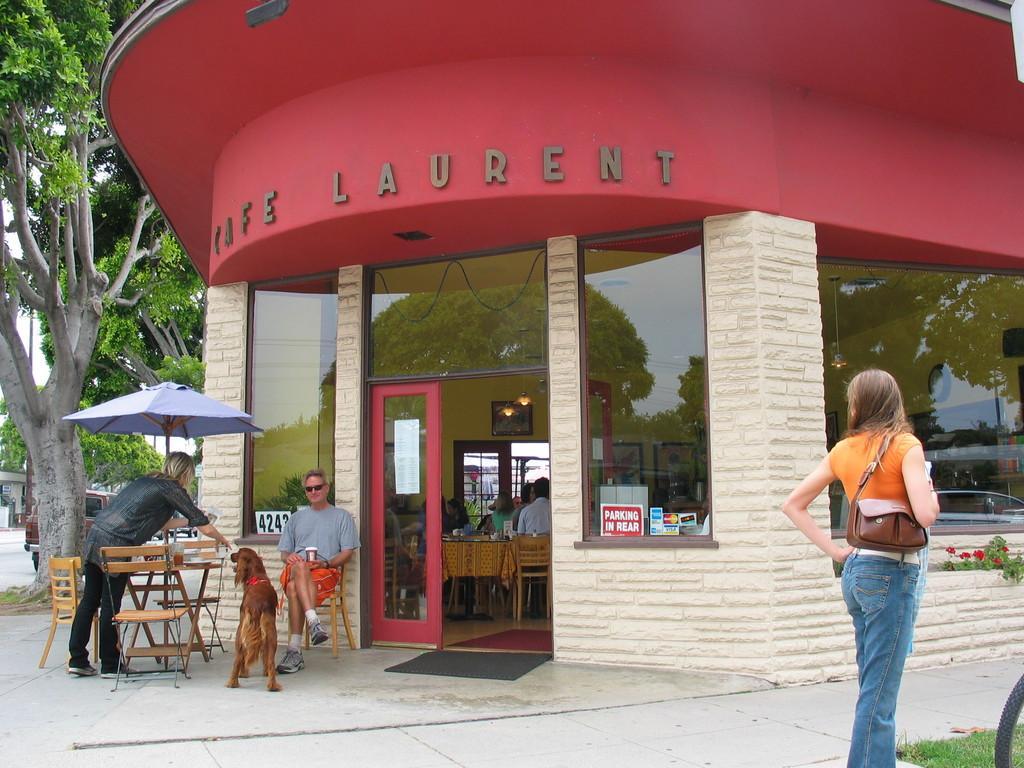How would you summarize this image in a sentence or two? This image consists of a restaurant in which there are tables and chairs. In the front, there is a dog in brown color. At the bottom, there is ground. To the left, there is are trees. To the right, there is a woman standing. 